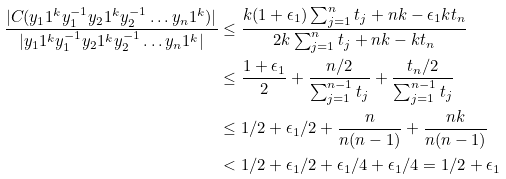Convert formula to latex. <formula><loc_0><loc_0><loc_500><loc_500>\frac { | C ( y _ { 1 } 1 ^ { k } y _ { 1 } ^ { - 1 } y _ { 2 } 1 ^ { k } y _ { 2 } ^ { - 1 } \dots y _ { n } 1 ^ { k } ) | } { | y _ { 1 } 1 ^ { k } y _ { 1 } ^ { - 1 } y _ { 2 } 1 ^ { k } y _ { 2 } ^ { - 1 } \dots y _ { n } 1 ^ { k } | } & \leq \frac { k ( 1 + \epsilon _ { 1 } ) \sum _ { j = 1 } ^ { n } t _ { j } + n k - \epsilon _ { 1 } k t _ { n } } { 2 k \sum _ { j = 1 } ^ { n } t _ { j } + n k - k t _ { n } } \\ & \leq \frac { 1 + \epsilon _ { 1 } } { 2 } + \frac { n / 2 } { \sum _ { j = 1 } ^ { n - 1 } t _ { j } } + \frac { t _ { n } / 2 } { \sum _ { j = 1 } ^ { n - 1 } t _ { j } } \\ & \leq 1 / 2 + \epsilon _ { 1 } / 2 + \frac { n } { n ( n - 1 ) } + \frac { n k } { n ( n - 1 ) } \\ & < 1 / 2 + \epsilon _ { 1 } / 2 + \epsilon _ { 1 } / 4 + \epsilon _ { 1 } / 4 = 1 / 2 + \epsilon _ { 1 }</formula> 